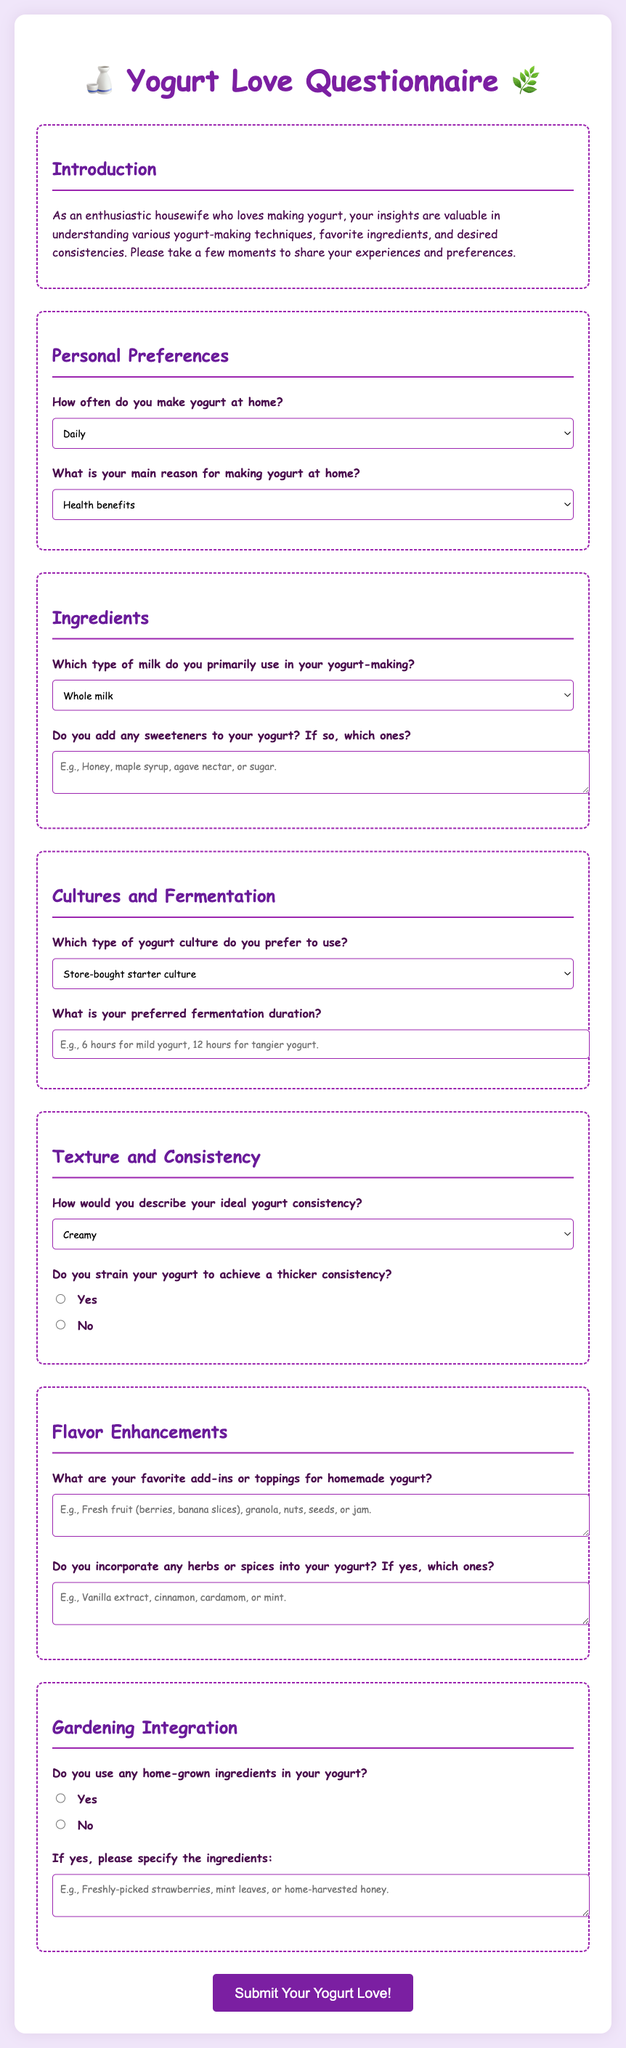What is the title of the questionnaire? The title clearly stated at the top of the document is "Yogurt Love Questionnaire".
Answer: Yogurt Love Questionnaire How often can respondents select for making yogurt at home? The options provided in the questionnaire include choices for how often yogurt is made, such as daily, weekly, etc.
Answer: Daily, Weekly, Monthly, Occasionally Which type of milk can be used according to the document? The document lists various types of milk that can be selected from the questionnaire for yogurt-making, such as whole milk and almond milk.
Answer: Whole milk, 2% milk, Skim milk, Goat milk, Almond milk, Soy milk What is one reason respondents might have for making yogurt at home? One selectable option in the questionnaire identifies possible motivations for making yogurt at home, such as health benefits.
Answer: Health benefits How are yogurt cultures categorized in the questionnaire? The types of yogurt cultures listed in the questionnaire include several options like store-bought starter culture and specialty cultures.
Answer: Store-bought starter culture, Previous batch of homemade yogurt, Probiotic capsules, Specialty cultures What consistency option is mentioned for yogurt? The questionnaire provides different options for describing desired yogurt consistency, such as creamy and thick and Greek-style.
Answer: Creamy, Thick and Greek-style, Smooth, Light and runny What ingredient did the questionnaire suggest for adding sweetness? The document mentions options for sweeteners that may be added to homemade yogurt, providing specific examples.
Answer: Honey, maple syrup, agave nectar, sugar What is one of the flavor enhancement suggestions in the document? The document provides several examples of add-ins or toppings for homemade yogurt, illustrating favorite flavor enhancements.
Answer: Fresh fruit, granola, nuts, seeds, jam Does the questionnaire inquire about using home-grown ingredients? The document contains a question specifically asking if respondents use any home-grown ingredients in their yogurt-making process.
Answer: Yes, No 